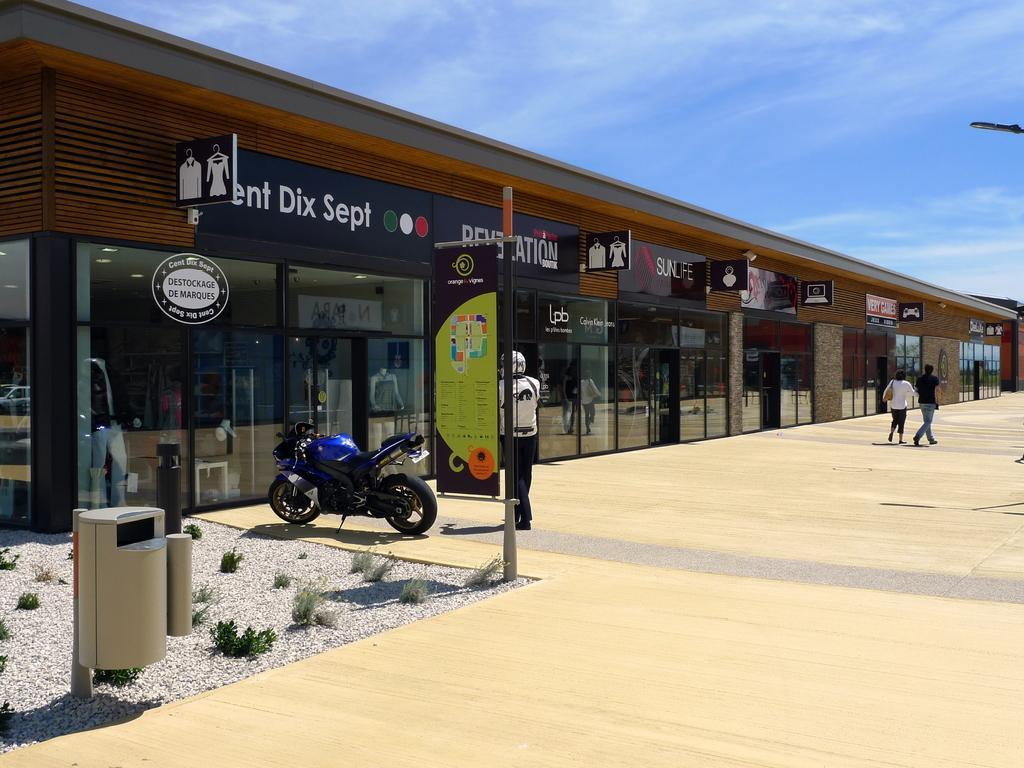How would you summarize this image in a sentence or two? In this image in the center there are persons walking and standing. In the background there is a building and there are boards with some text written on it, and the sky is cloudy and there is a bike in the center. In the front there are poles and there are stones on the ground and there are plants. 